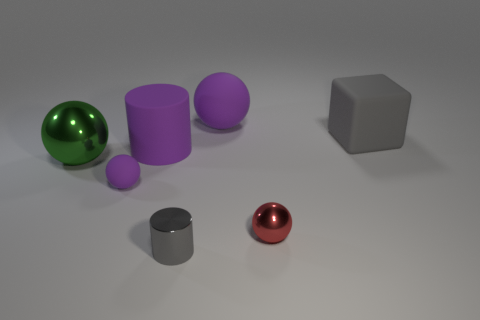What shape is the small metal thing that is on the right side of the gray object in front of the red shiny ball?
Provide a short and direct response. Sphere. How many objects are either objects that are in front of the tiny purple sphere or metal balls that are on the right side of the gray metallic thing?
Make the answer very short. 2. What shape is the tiny gray thing that is the same material as the small red object?
Offer a very short reply. Cylinder. Are there any other things of the same color as the big cube?
Your response must be concise. Yes. There is another tiny object that is the same shape as the tiny red object; what is its material?
Give a very brief answer. Rubber. What number of other things are the same size as the red ball?
Give a very brief answer. 2. What is the cube made of?
Provide a succinct answer. Rubber. Are there more small metal objects that are right of the red sphere than rubber blocks?
Keep it short and to the point. No. Is there a small purple object?
Provide a succinct answer. Yes. What number of other objects are there of the same shape as the red shiny thing?
Your answer should be compact. 3. 